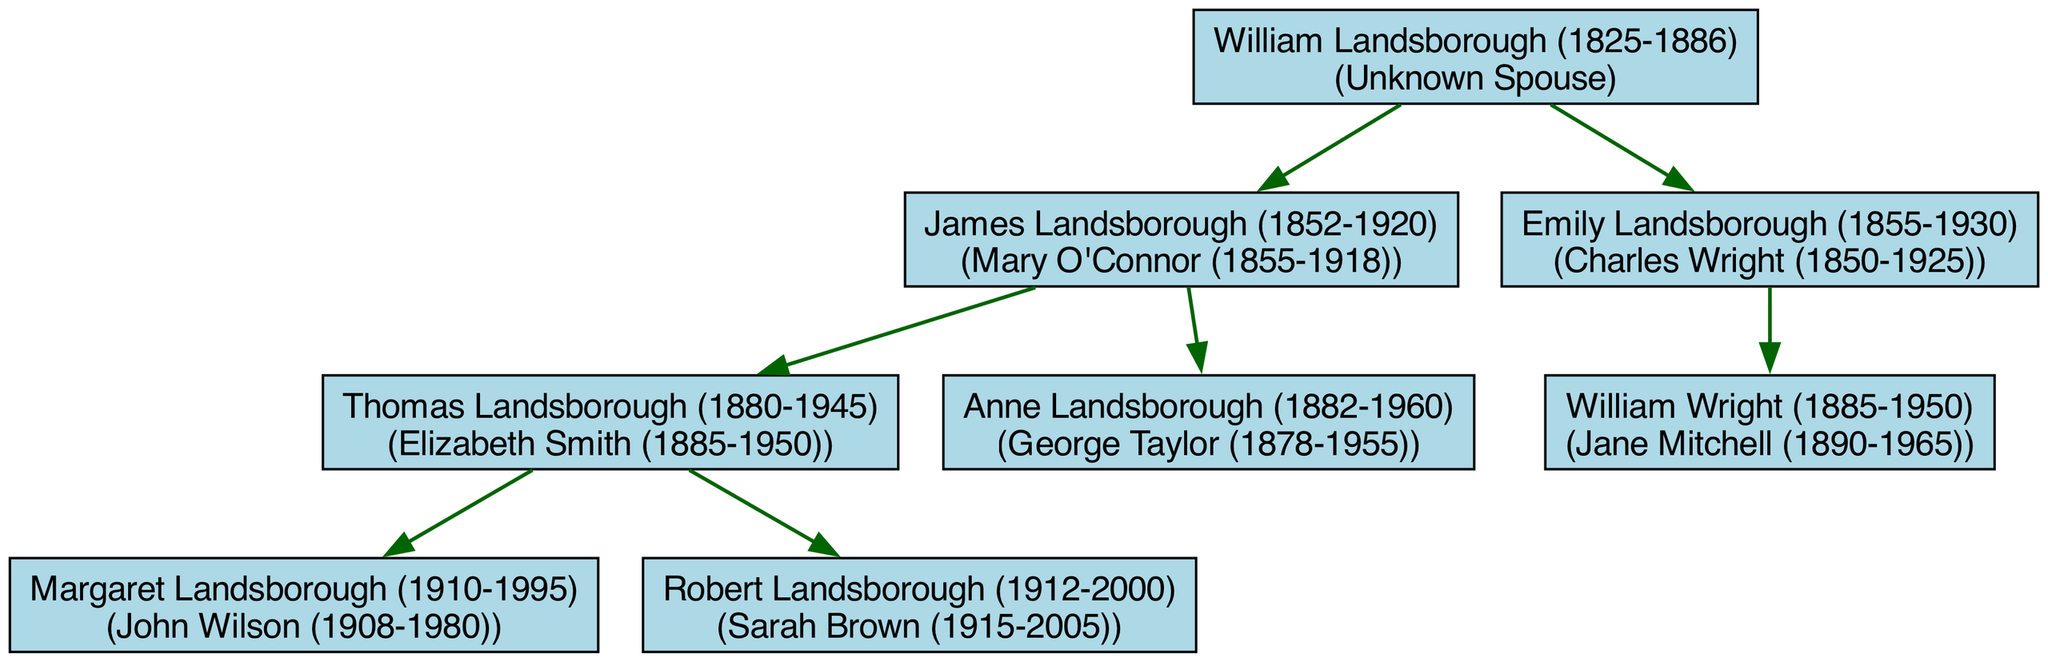What is the name of William Landsborough's spouse? The diagram shows William Landsborough as the root person, but it doesn't list a spouse for him. Therefore, the information isn't available.
Answer: Unknown Spouse How many children did James Landsborough have? Looking at the diagram, James Landsborough has two children listed: Thomas Landsborough and Anne Landsborough. Therefore, the total number of children is two.
Answer: 2 Who is the spouse of Emily Landsborough? The subtree for Emily Landsborough indicates that she is married to Charles Wright, as shown in the diagram.
Answer: Charles Wright Which child of James Landsborough married Sarah Brown? The diagram indicates that Robert Landsborough, who is a child of James Landsborough, married Sarah Brown.
Answer: Robert Landsborough How many grandparents are represented in the diagram? The only grandparent shown in the diagram is William Landsborough. Since only one root person is indicated, the total is one.
Answer: 1 Who is the mother of Margaret Landsborough? Referring to the diagram, Margaret Landsborough is a child of Thomas Landsborough and Elizabeth Smith. Thus, her mother is Elizabeth Smith.
Answer: Elizabeth Smith Which couple has only one child in the diagram? Emily Landsborough and Charles Wright are shown to have only one child, William Wright, which indicates that they are the couple with only one child.
Answer: Emily Landsborough and Charles Wright What are the years of birth and death of Thomas Landsborough? The diagram specifies that Thomas Landsborough was born in 1880 and died in 1945. Thus, both years can be easily traced from the labeled node.
Answer: 1880-1945 Who was married to George Taylor? The diagram states that Anne Landsborough is married to George Taylor, linking them directly within the family structure.
Answer: Anne Landsborough 